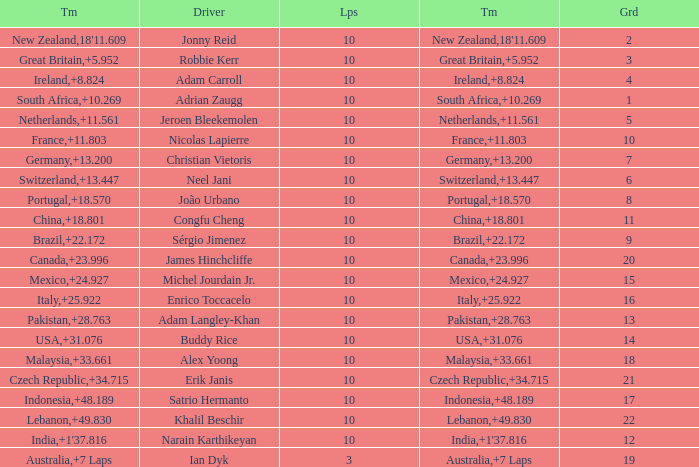For what Team is Narain Karthikeyan the Driver? India. 